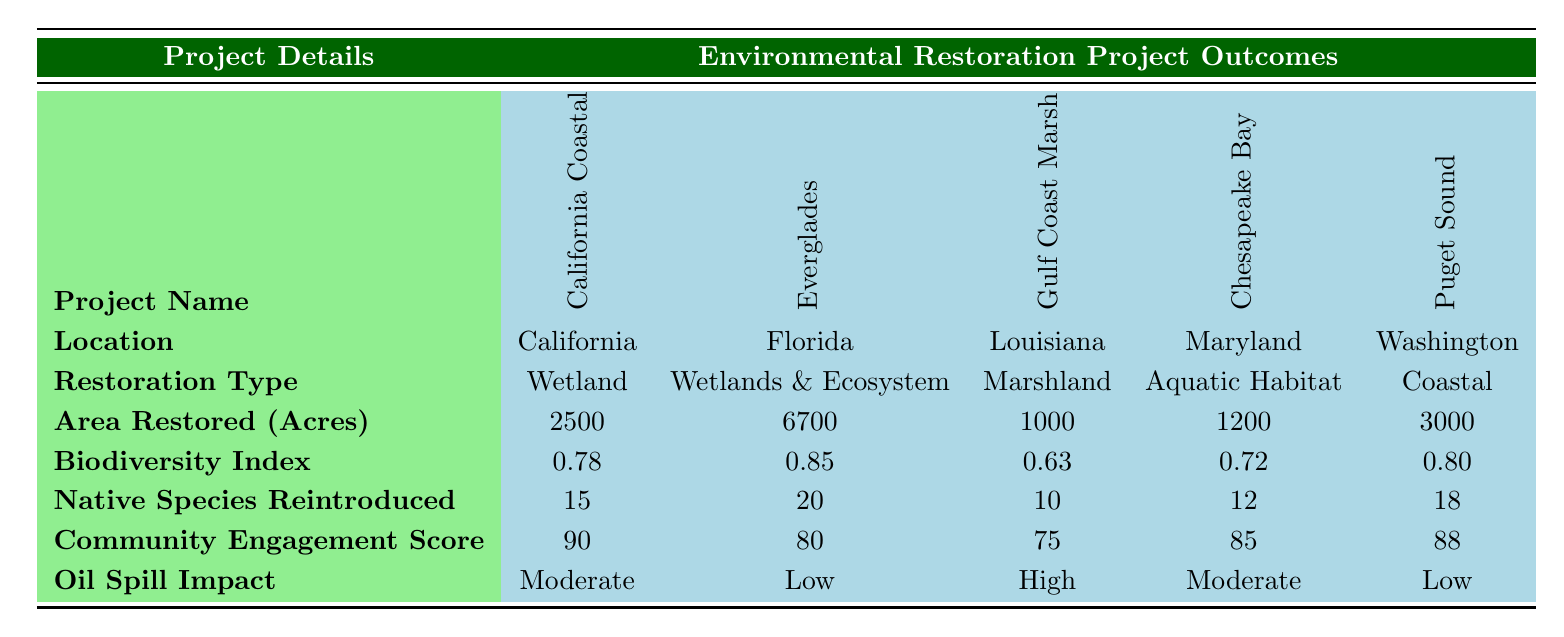What is the total area restored by all projects combined? To find the total area restored, I will add the area restored for each project: 2500 + 6700 + 1000 + 1200 + 3000 = 19100 acres.
Answer: 19100 acres Which project has the highest biodiversity index? By comparing the biodiversity index values provided, I see that the Everglades Restoration Plan has the highest index at 0.85.
Answer: Everglades Restoration Plan Is the oil spill impact high for any project listed? Looking through the oil spill impact column, I see that only the Gulf Coast Marsh Restoration project has a "High" impact.
Answer: Yes What is the average community engagement score for the projects? To find the average, I will add the community engagement scores: 90 + 80 + 75 + 85 + 88 = 418, then divide by the number of projects (5): 418 / 5 = 83.6.
Answer: 83.6 How many native species were reintroduced in total? I will sum the native species reintroduced from each project: 15 + 20 + 10 + 12 + 18 = 85.
Answer: 85 Is the Chesapeake Bay Watershed Restoration project located in Florida? Referring to the location column, the Chesapeake Bay Watershed Restoration project is actually located in Maryland, not Florida.
Answer: No Which project had the lowest area restored? Comparing the area restored across all projects, I see that the Gulf Coast Marsh Restoration had the lowest, with 1000 acres.
Answer: Gulf Coast Marsh Restoration Which two projects have a community engagement score above 85? I will examine the community engagement scores and find that the California Coastal Restoration Initiative (90) and Puget Sound Recovery Project (88) both exceed a score of 85.
Answer: California Coastal Restoration Initiative and Puget Sound Recovery Project How does the biodiversity index of the Puget Sound Recovery Project compare with the Gulf Coast Marsh Restoration? The Puget Sound Recovery Project has a biodiversity index of 0.80, while the Gulf Coast Marsh Restoration has a lower index at 0.63, indicating that Puget Sound has a higher biodiversity.
Answer: Higher 